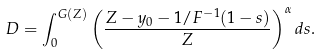<formula> <loc_0><loc_0><loc_500><loc_500>D = \int _ { 0 } ^ { G ( Z ) } \left ( \frac { Z - y _ { 0 } - 1 / F ^ { - 1 } ( 1 - s ) } { Z } \right ) ^ { \alpha } d s .</formula> 